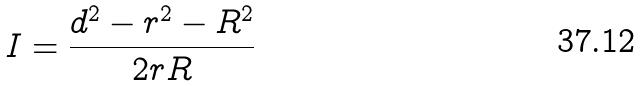Convert formula to latex. <formula><loc_0><loc_0><loc_500><loc_500>I = \frac { d ^ { 2 } - r ^ { 2 } - R ^ { 2 } } { 2 r R }</formula> 